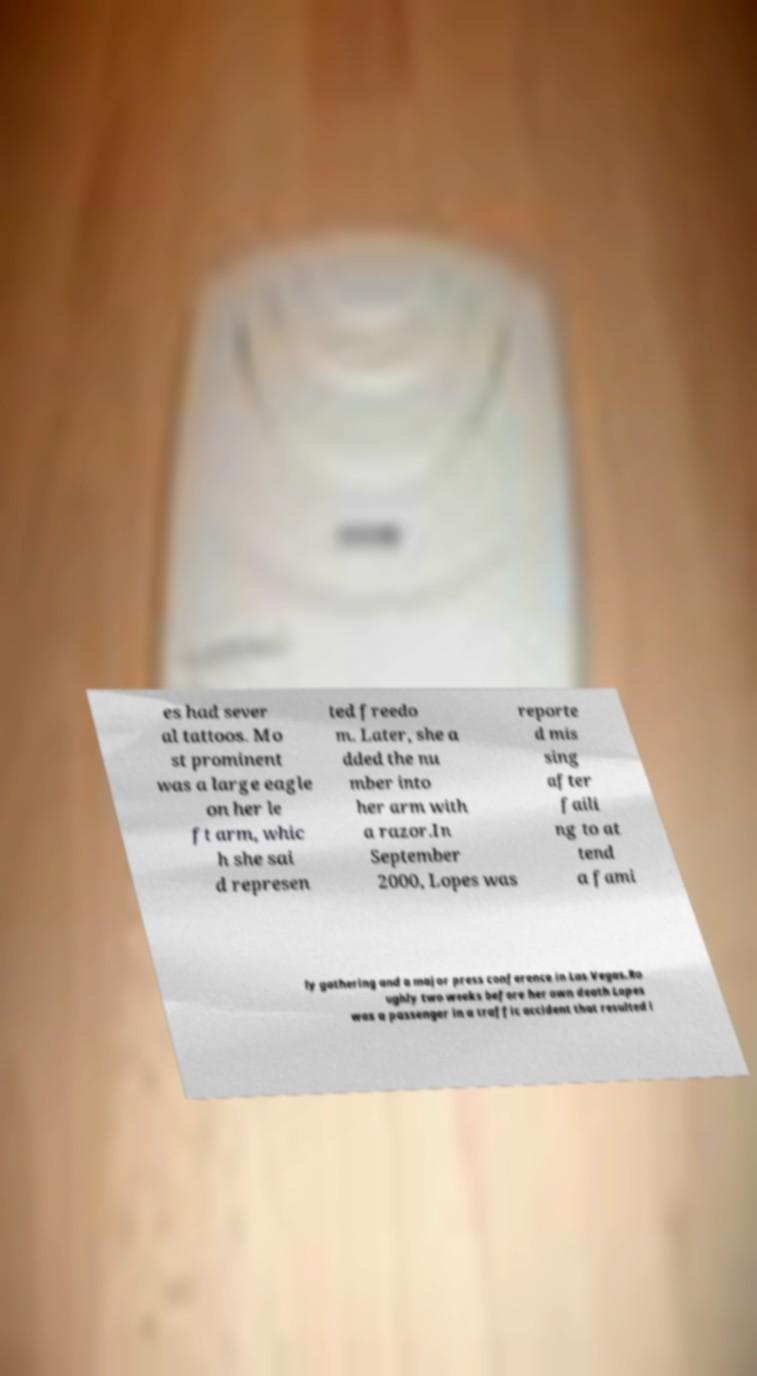Please identify and transcribe the text found in this image. es had sever al tattoos. Mo st prominent was a large eagle on her le ft arm, whic h she sai d represen ted freedo m. Later, she a dded the nu mber into her arm with a razor.In September 2000, Lopes was reporte d mis sing after faili ng to at tend a fami ly gathering and a major press conference in Las Vegas.Ro ughly two weeks before her own death Lopes was a passenger in a traffic accident that resulted i 